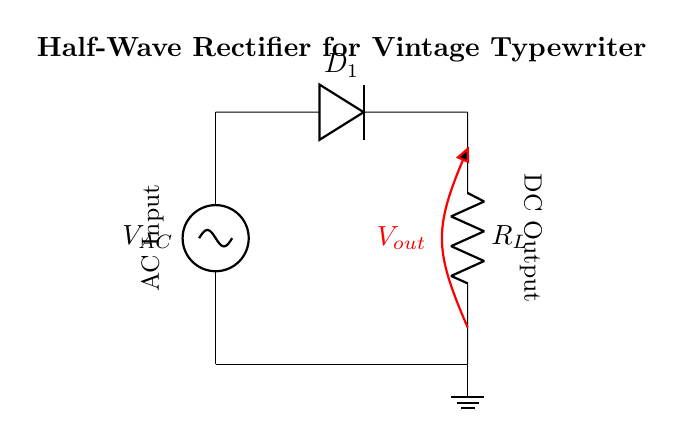What is the type of circuit shown? The circuit is a half-wave rectifier, identifiable by the presence of a single diode that allows current to pass during one half of the AC cycle while blocking the other half.
Answer: Half-wave rectifier How many diodes are used in the circuit? There is one diode in the circuit, which is responsible for the rectification process. The diode is denoted as D1 in the diagram.
Answer: One What does the resistor R_L represent? The resistor R_L represents the load in the circuit, which consumes the DC power converted from the AC source. It is connected in series with the diode.
Answer: Load resistor What is the direction of current flow during the positive half-cycle? During the positive half-cycle of the AC input, the current flows from the AC source, through the diode D1, and into the load resistor R_L. This is due to the forward biasing of the diode in this half-cycle.
Answer: From source to load What kind of voltage is indicated by V_out? V_out represents the output voltage of the half-wave rectifier circuit, which will be a pulsating DC voltage following the application of an AC input. This voltage is taken across the load resistor R_L.
Answer: Pulsating DC voltage Why is this circuit not rated for continuous current? The half-wave rectifier only allows current to flow during one half of the AC cycle, resulting in a significant amount of time where no current flows. This intermittent nature leads to lower average output current, making it unsuitable for applications requiring continuous current.
Answer: Intermittent current flow 